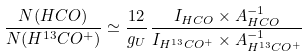Convert formula to latex. <formula><loc_0><loc_0><loc_500><loc_500>\frac { N ( H C O ) } { N ( H ^ { 1 3 } C O ^ { + } ) } \simeq \frac { 1 2 } { g _ { U } } \, \frac { I _ { H C O } \times A ^ { - 1 } _ { H C O } } { I _ { H ^ { 1 3 } C O ^ { + } } \times A ^ { - 1 } _ { H ^ { 1 3 } C O ^ { + } } }</formula> 